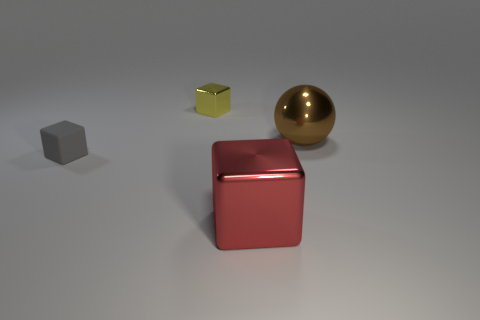What is the brown sphere made of?
Provide a succinct answer. Metal. What number of shiny cubes are there?
Give a very brief answer. 2. There is a block that is left of the tiny metal thing; does it have the same color as the big metal object that is on the right side of the large metal block?
Your answer should be very brief. No. How many other things are the same size as the red metal thing?
Provide a short and direct response. 1. What color is the shiny thing that is in front of the rubber cube?
Provide a short and direct response. Red. Does the cube on the right side of the small yellow thing have the same material as the large brown sphere?
Keep it short and to the point. Yes. How many things are both to the right of the small metal block and on the left side of the brown sphere?
Offer a very short reply. 1. The thing right of the cube right of the shiny object behind the shiny sphere is what color?
Your answer should be very brief. Brown. What number of other things are the same shape as the yellow shiny thing?
Keep it short and to the point. 2. There is a matte object that is on the left side of the ball; are there any small objects to the right of it?
Make the answer very short. Yes. 